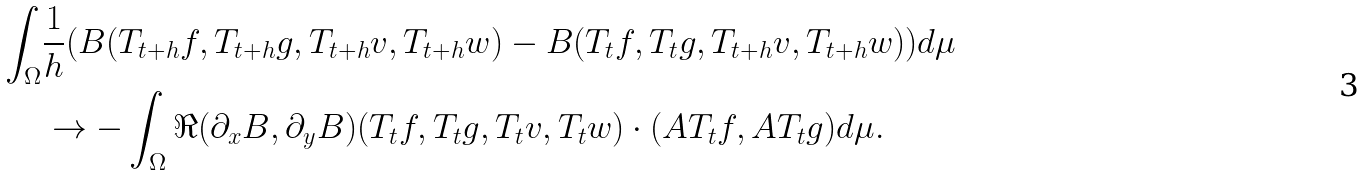<formula> <loc_0><loc_0><loc_500><loc_500>\int _ { \Omega } & \frac { 1 } { h } ( B ( T _ { t + h } f , T _ { t + h } g , T _ { t + h } v , T _ { t + h } w ) - B ( T _ { t } f , T _ { t } g , T _ { t + h } v , T _ { t + h } w ) ) d \mu \\ & \to - \int _ { \Omega } \Re ( \partial _ { x } B , \partial _ { y } B ) ( T _ { t } f , T _ { t } g , T _ { t } v , T _ { t } w ) \cdot ( A T _ { t } f , A T _ { t } g ) d \mu .</formula> 